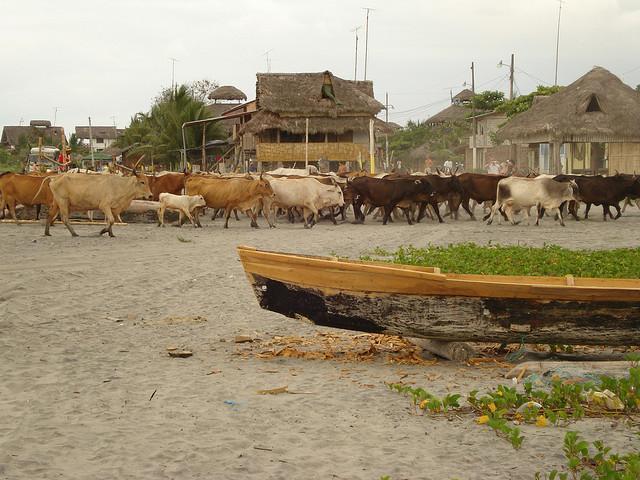What roofing method was used on these houses?
Select the accurate answer and provide explanation: 'Answer: answer
Rationale: rationale.'
Options: Wicked, raftered, gabled, thatching. Answer: thatching.
Rationale: The houses' rooftops have thatching. 